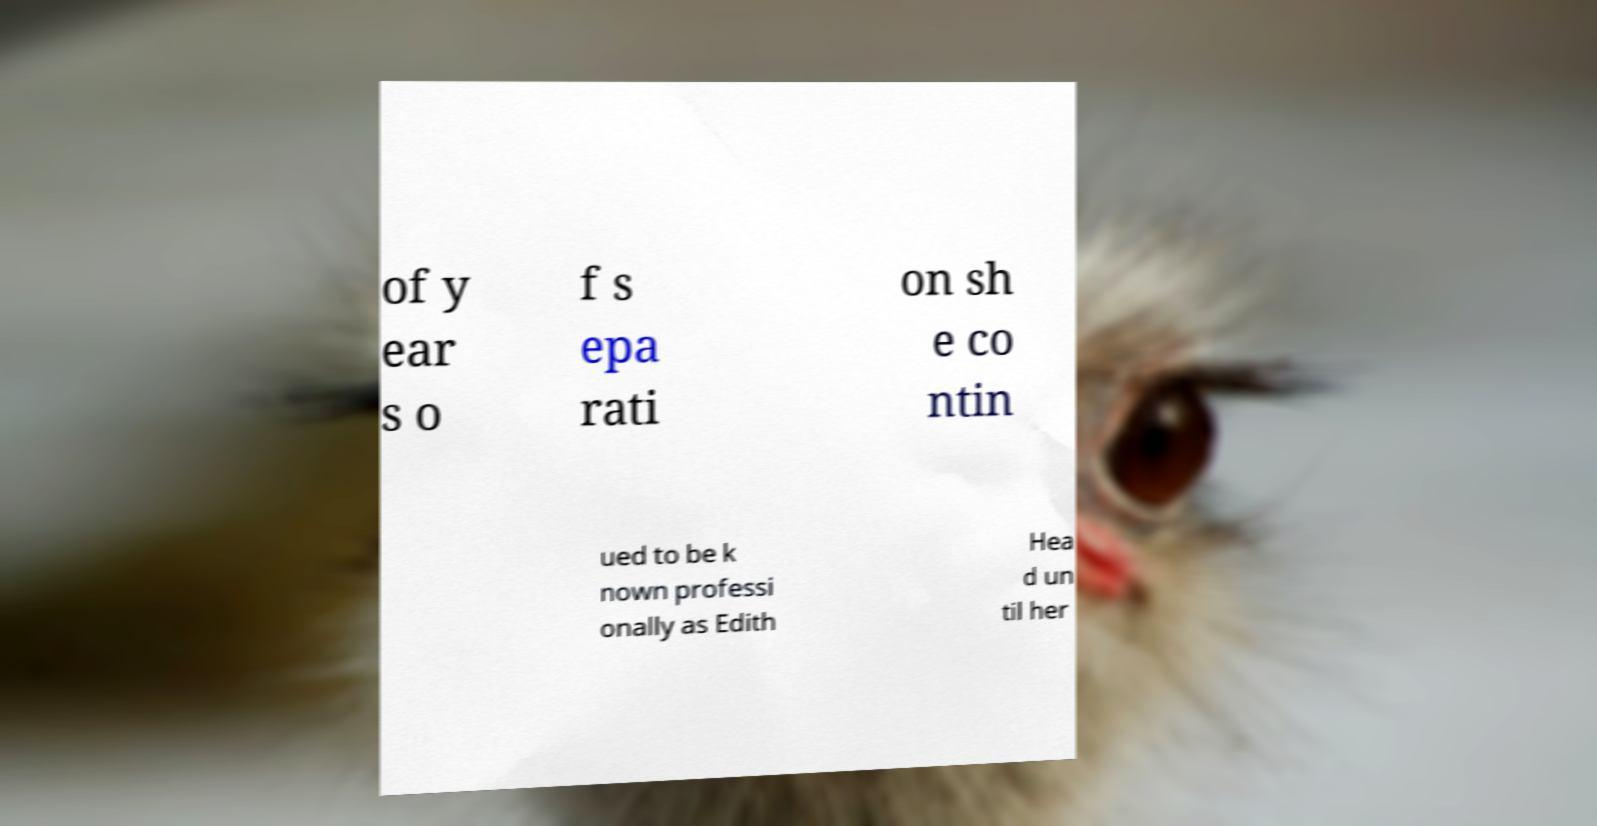Please read and relay the text visible in this image. What does it say? of y ear s o f s epa rati on sh e co ntin ued to be k nown professi onally as Edith Hea d un til her 